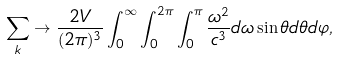Convert formula to latex. <formula><loc_0><loc_0><loc_500><loc_500>\sum _ { k } \rightarrow \frac { 2 V } { ( 2 \pi ) ^ { 3 } } \int _ { 0 } ^ { \infty } \int _ { 0 } ^ { 2 \pi } \int _ { 0 } ^ { \pi } \frac { \omega ^ { 2 } } { c ^ { 3 } } d \omega \sin \theta d \theta d \varphi ,</formula> 